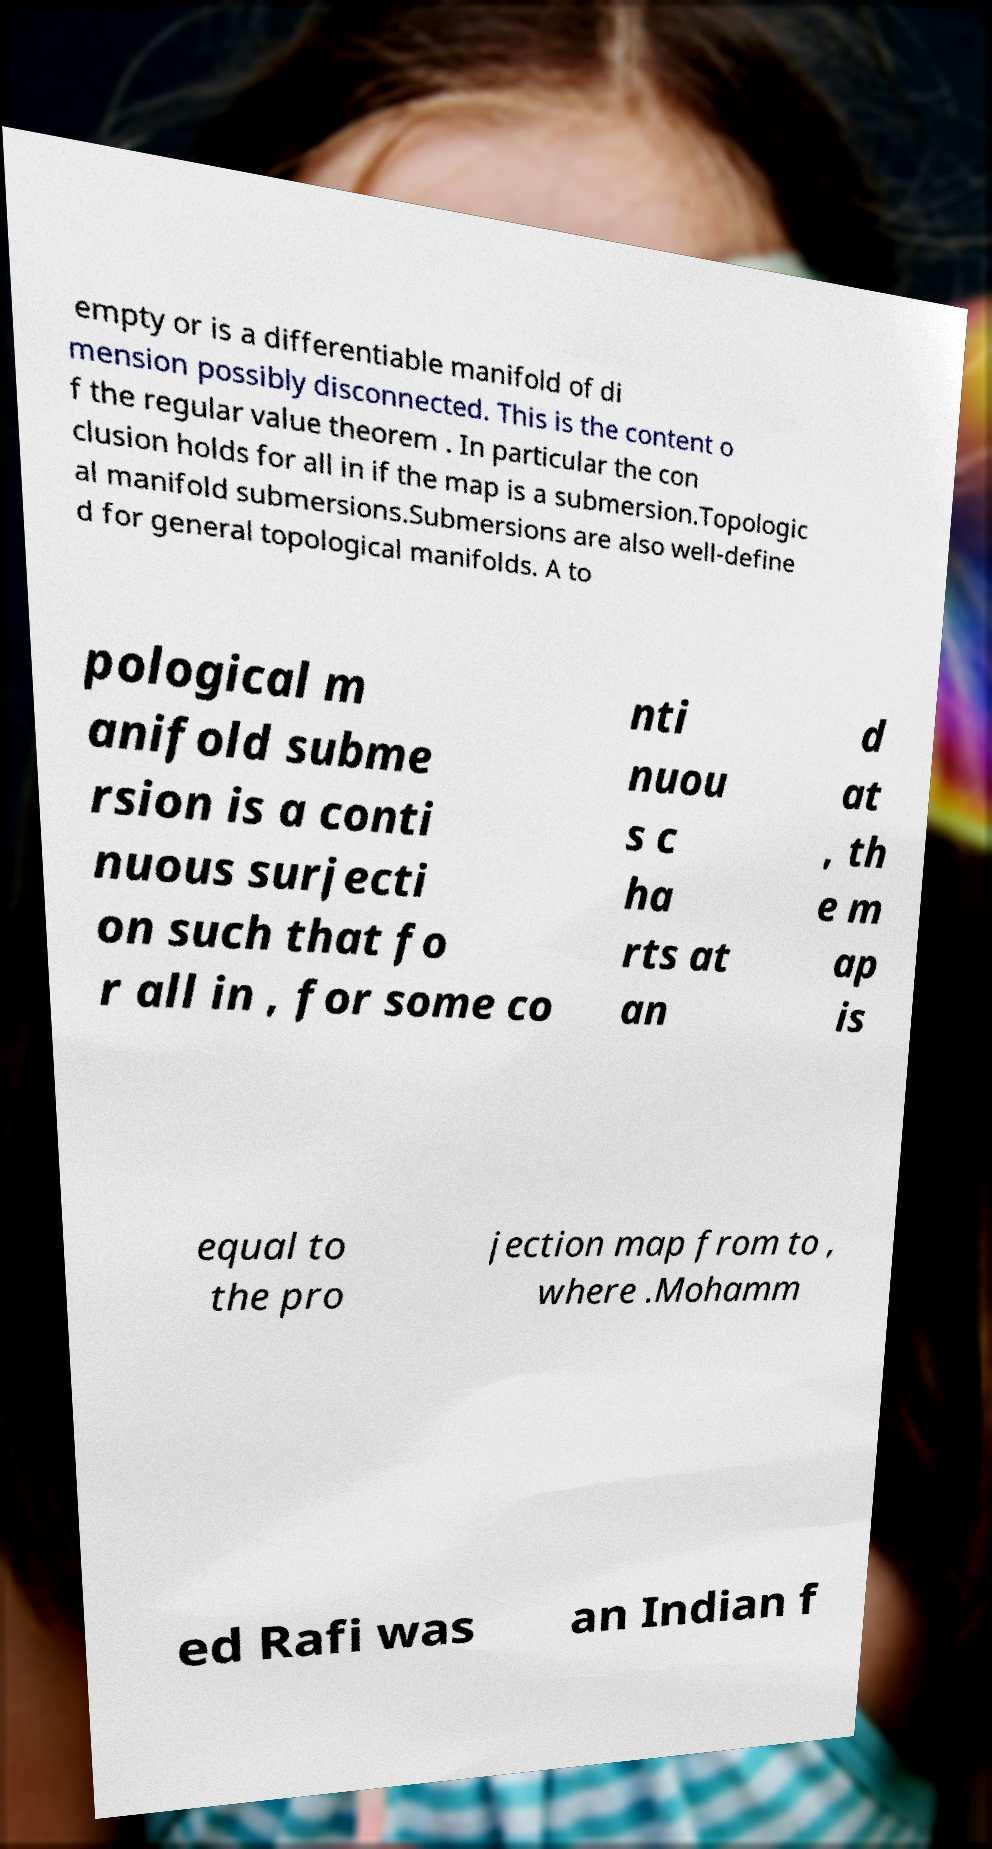Please read and relay the text visible in this image. What does it say? empty or is a differentiable manifold of di mension possibly disconnected. This is the content o f the regular value theorem . In particular the con clusion holds for all in if the map is a submersion.Topologic al manifold submersions.Submersions are also well-define d for general topological manifolds. A to pological m anifold subme rsion is a conti nuous surjecti on such that fo r all in , for some co nti nuou s c ha rts at an d at , th e m ap is equal to the pro jection map from to , where .Mohamm ed Rafi was an Indian f 